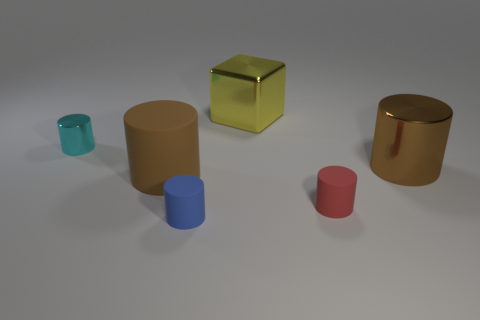Add 2 small things. How many objects exist? 8 Subtract all blue matte cylinders. How many cylinders are left? 4 Subtract 1 cubes. How many cubes are left? 0 Subtract all brown cylinders. How many cylinders are left? 3 Subtract all cyan blocks. Subtract all blue cylinders. How many blocks are left? 1 Subtract all brown balls. How many blue cylinders are left? 1 Subtract 0 brown balls. How many objects are left? 6 Subtract all cylinders. How many objects are left? 1 Subtract all metallic balls. Subtract all large yellow blocks. How many objects are left? 5 Add 4 big rubber cylinders. How many big rubber cylinders are left? 5 